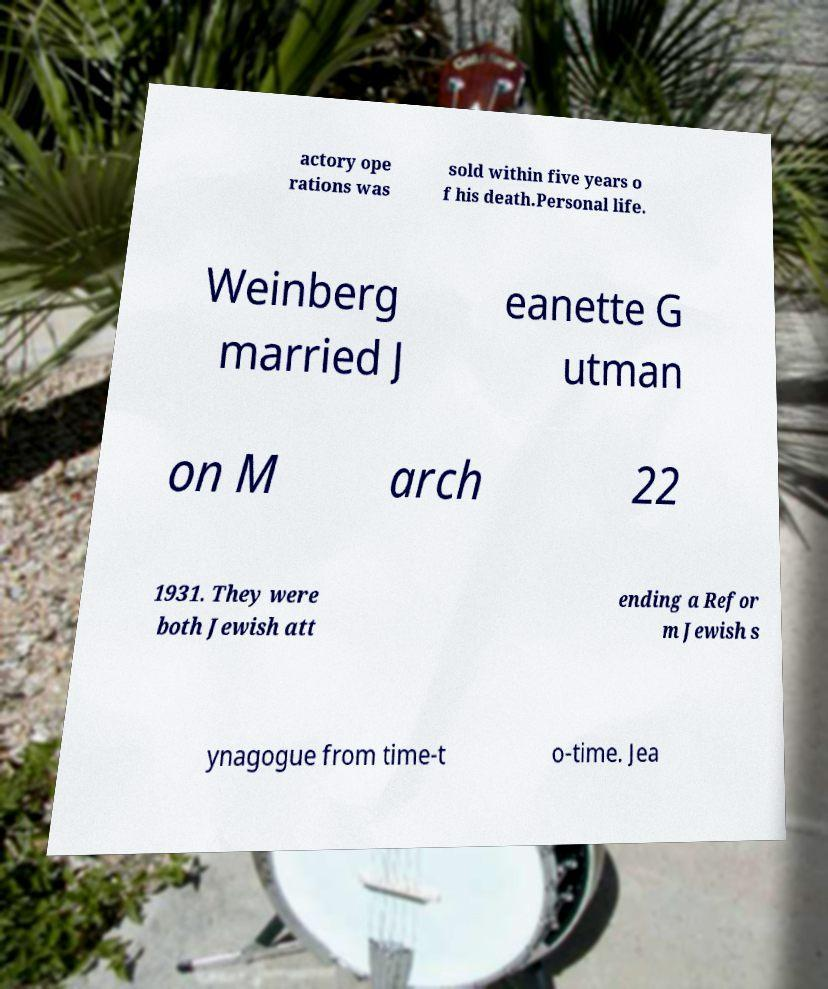Can you read and provide the text displayed in the image?This photo seems to have some interesting text. Can you extract and type it out for me? actory ope rations was sold within five years o f his death.Personal life. Weinberg married J eanette G utman on M arch 22 1931. They were both Jewish att ending a Refor m Jewish s ynagogue from time-t o-time. Jea 